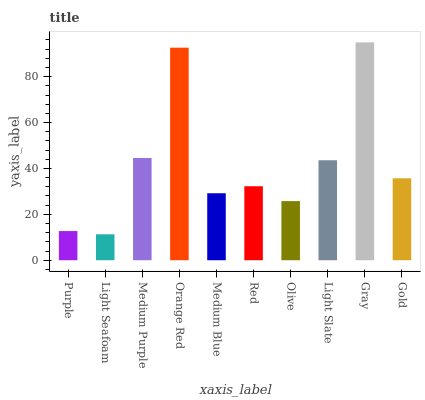Is Light Seafoam the minimum?
Answer yes or no. Yes. Is Gray the maximum?
Answer yes or no. Yes. Is Medium Purple the minimum?
Answer yes or no. No. Is Medium Purple the maximum?
Answer yes or no. No. Is Medium Purple greater than Light Seafoam?
Answer yes or no. Yes. Is Light Seafoam less than Medium Purple?
Answer yes or no. Yes. Is Light Seafoam greater than Medium Purple?
Answer yes or no. No. Is Medium Purple less than Light Seafoam?
Answer yes or no. No. Is Gold the high median?
Answer yes or no. Yes. Is Red the low median?
Answer yes or no. Yes. Is Purple the high median?
Answer yes or no. No. Is Light Slate the low median?
Answer yes or no. No. 